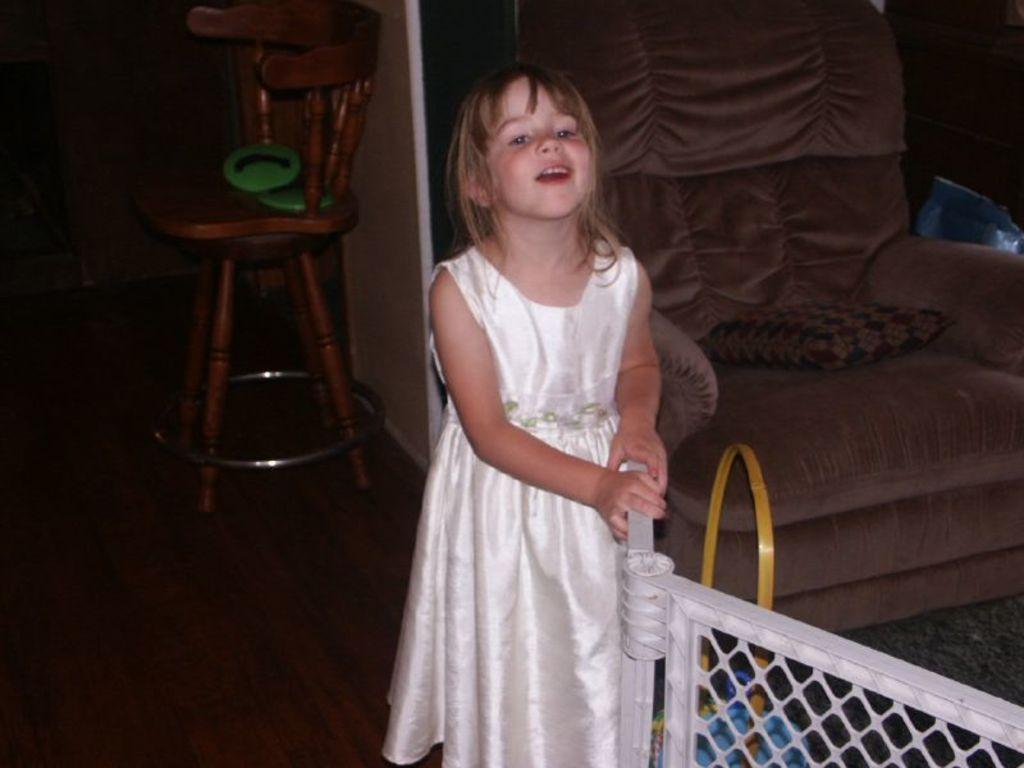In one or two sentences, can you explain what this image depicts? In this image i can see a girl standing. In the background i can see a chair, a wall and a couch. 